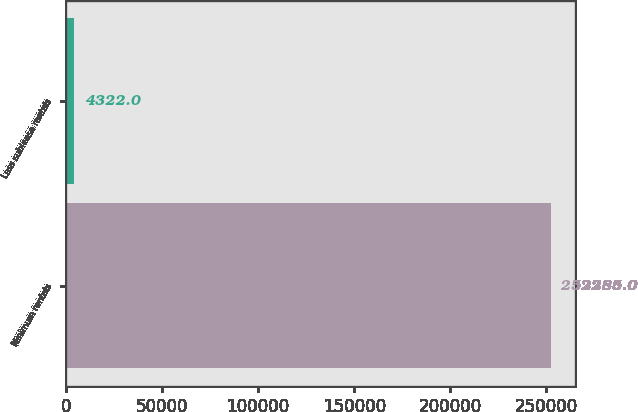Convert chart. <chart><loc_0><loc_0><loc_500><loc_500><bar_chart><fcel>Minimum rentals<fcel>Less sublease rentals<nl><fcel>252285<fcel>4322<nl></chart> 